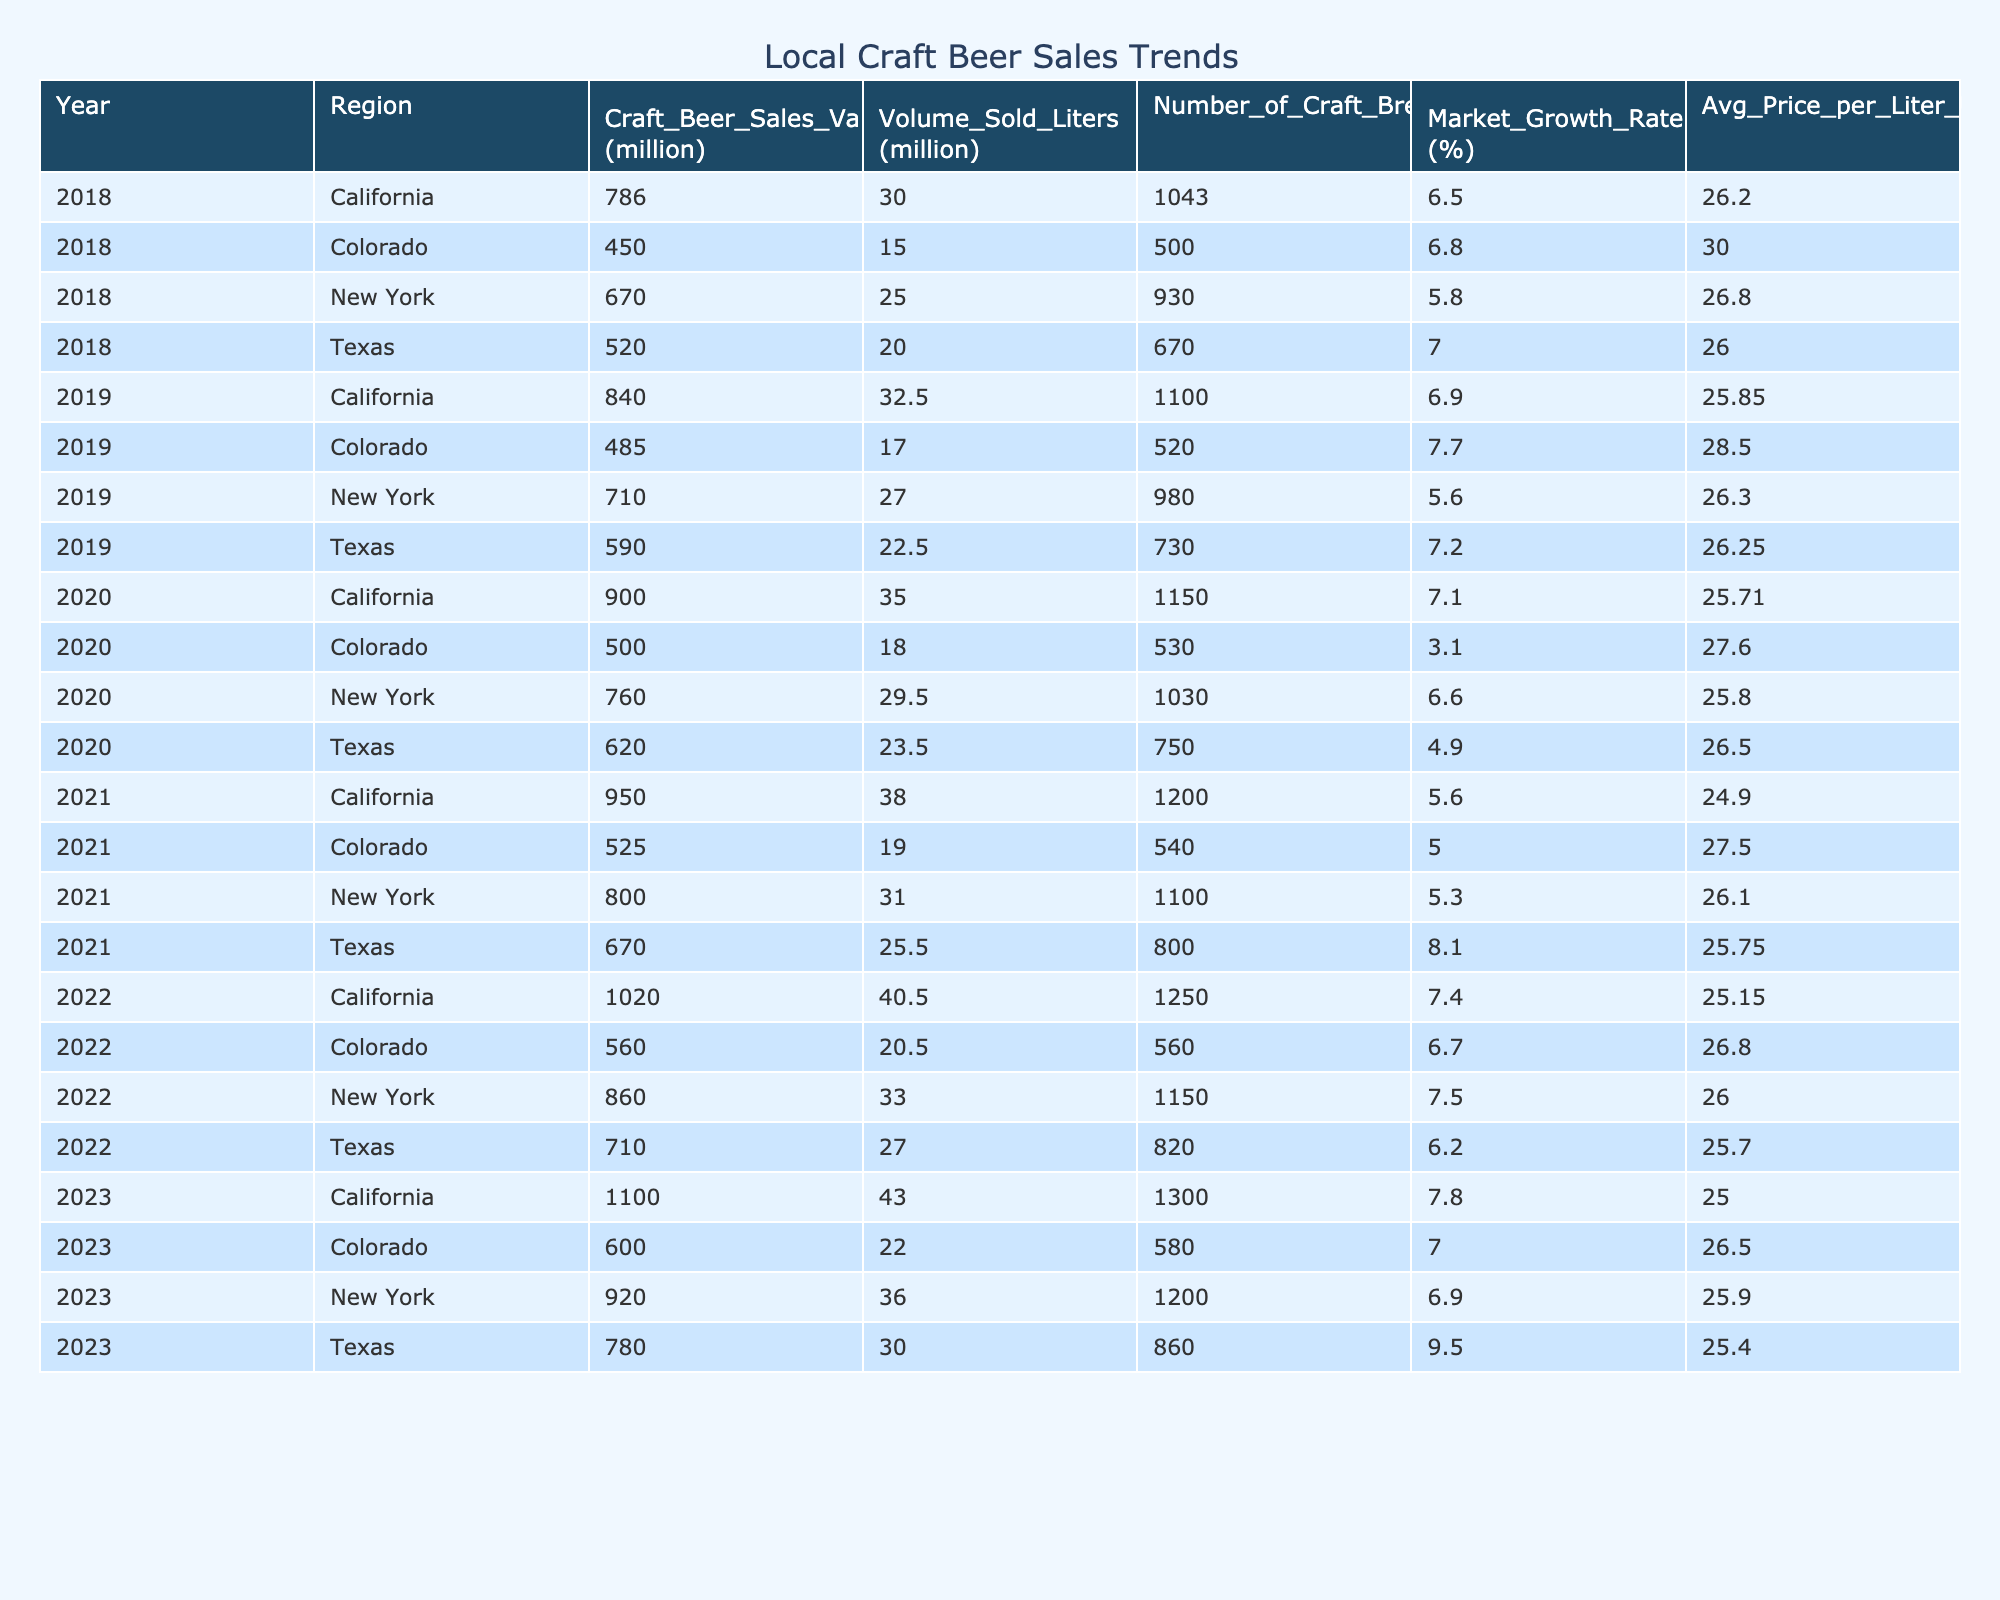What was the craft beer sales value in California in 2022? In the table, for California in the row that corresponds to the year 2022, the craft beer sales value is shown as 1020 million USD.
Answer: 1020 million USD What is the average market growth rate for craft beer sales in Texas from 2018 to 2023? To find the average market growth rate, sum the growth rates from the years (7.0, 7.2, 4.9, 8.1, 6.2, 9.5) which totals to 43.0. Then, divide by the number of years (6) to get the average: 43.0 / 6 = 7.17%.
Answer: 7.17% Did New York experience a year-on-year increase in craft beer sales value every year from 2018 to 2023? By examining the yearly values for New York, the yearly sales values are: 670, 710, 760, 800, 860, 920. All these values show an increase each year, hence, New York did experience a year-on-year increase.
Answer: Yes Which region had the highest average price per liter of craft beer in 2018? Looking at the values in the "Avg Price per Liter USD" for the year 2018, California is 26.20, New York is 26.80, Texas is 26.00, and Colorado is 30.00. Colorado has the highest average price per liter.
Answer: Colorado What was the total volume of craft beer sold in California from 2019 to 2023? For California, the sold volumes from 2019 to 2023 are 32.5, 35.0, 38.0, 40.5, and 43.0 million liters. Summing these gives: 32.5 + 35.0 + 38.0 + 40.5 + 43.0 = 189.0 million liters.
Answer: 189.0 million liters In which year did Texas have the lowest market growth rate during the observed period? The market growth rates for Texas are listed as (7.0, 7.2, 4.9, 8.1, 6.2, 9.5). The lowest value among these is 4.9 in 2020.
Answer: 2020 How many craft breweries were operating in New York in 2021? The number of craft breweries in New York for the year 2021 is explicitly stated in the table as 1100.
Answer: 1100 Which region experienced the highest total craft beer sales value across all years listed? Summing the total sales for each region: California (786 + 840 + 900 + 950 + 1020 + 1100 = 4696), New York (670 + 710 + 760 + 800 + 860 + 920 = 3920), Texas (520 + 590 + 620 + 670 + 710 + 780 = 3890), Colorado (450 + 485 + 500 + 525 + 560 + 600 = 3120). California had the highest total sales value of 4696 million USD.
Answer: California 